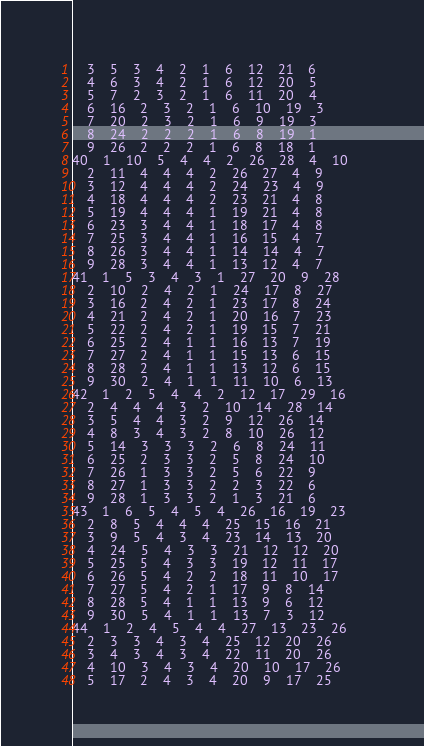Convert code to text. <code><loc_0><loc_0><loc_500><loc_500><_ObjectiveC_>	3	5	3	4	2	1	6	12	21	6	
	4	6	3	4	2	1	6	12	20	5	
	5	7	2	3	2	1	6	11	20	4	
	6	16	2	3	2	1	6	10	19	3	
	7	20	2	3	2	1	6	9	19	3	
	8	24	2	2	2	1	6	8	19	1	
	9	26	2	2	2	1	6	8	18	1	
40	1	10	5	4	4	2	26	28	4	10	
	2	11	4	4	4	2	26	27	4	9	
	3	12	4	4	4	2	24	23	4	9	
	4	18	4	4	4	2	23	21	4	8	
	5	19	4	4	4	1	19	21	4	8	
	6	23	3	4	4	1	18	17	4	8	
	7	25	3	4	4	1	16	15	4	7	
	8	26	3	4	4	1	14	14	4	7	
	9	28	3	4	4	1	13	12	4	7	
41	1	5	3	4	3	1	27	20	9	28	
	2	10	2	4	2	1	24	17	8	27	
	3	16	2	4	2	1	23	17	8	24	
	4	21	2	4	2	1	20	16	7	23	
	5	22	2	4	2	1	19	15	7	21	
	6	25	2	4	1	1	16	13	7	19	
	7	27	2	4	1	1	15	13	6	15	
	8	28	2	4	1	1	13	12	6	15	
	9	30	2	4	1	1	11	10	6	13	
42	1	2	5	4	4	2	12	17	29	16	
	2	4	4	4	3	2	10	14	28	14	
	3	5	4	4	3	2	9	12	26	14	
	4	8	3	4	3	2	8	10	26	12	
	5	14	3	3	3	2	6	8	24	11	
	6	25	2	3	3	2	5	8	24	10	
	7	26	1	3	3	2	5	6	22	9	
	8	27	1	3	3	2	2	3	22	6	
	9	28	1	3	3	2	1	3	21	6	
43	1	6	5	4	5	4	26	16	19	23	
	2	8	5	4	4	4	25	15	16	21	
	3	9	5	4	3	4	23	14	13	20	
	4	24	5	4	3	3	21	12	12	20	
	5	25	5	4	3	3	19	12	11	17	
	6	26	5	4	2	2	18	11	10	17	
	7	27	5	4	2	1	17	9	8	14	
	8	28	5	4	1	1	13	9	6	12	
	9	30	5	4	1	1	13	7	3	12	
44	1	2	4	5	4	4	27	13	23	26	
	2	3	3	4	3	4	25	12	20	26	
	3	4	3	4	3	4	22	11	20	26	
	4	10	3	4	3	4	20	10	17	26	
	5	17	2	4	3	4	20	9	17	25	</code> 